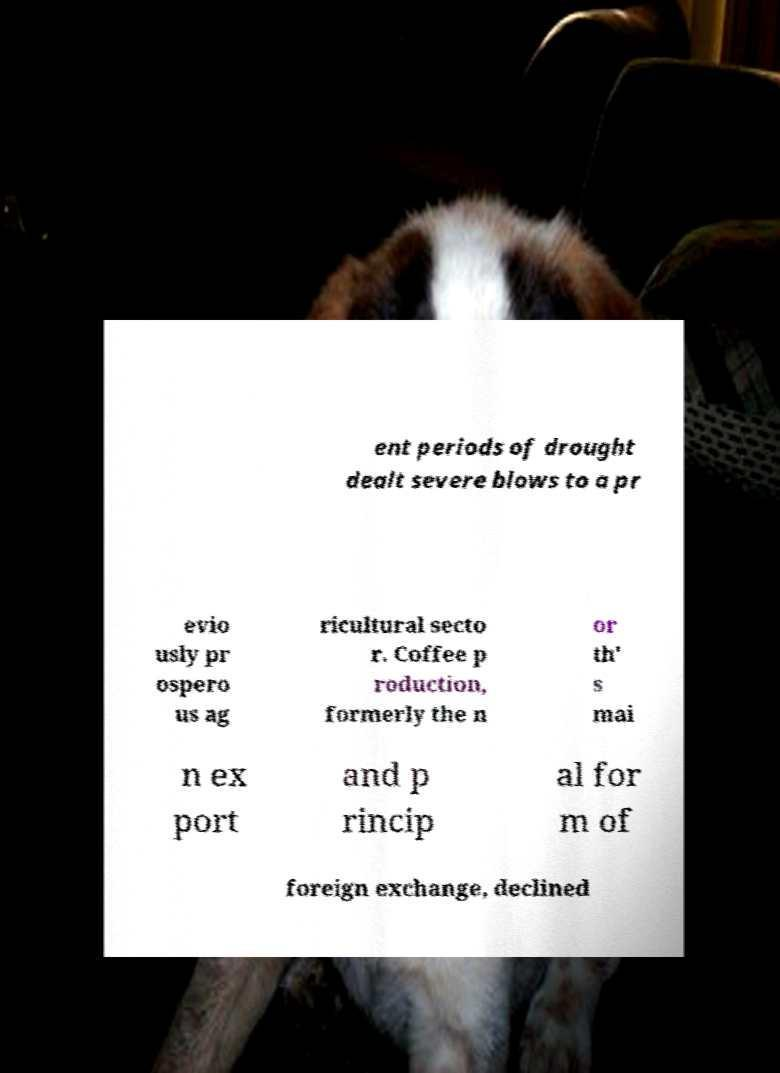Please identify and transcribe the text found in this image. ent periods of drought dealt severe blows to a pr evio usly pr ospero us ag ricultural secto r. Coffee p roduction, formerly the n or th' s mai n ex port and p rincip al for m of foreign exchange, declined 